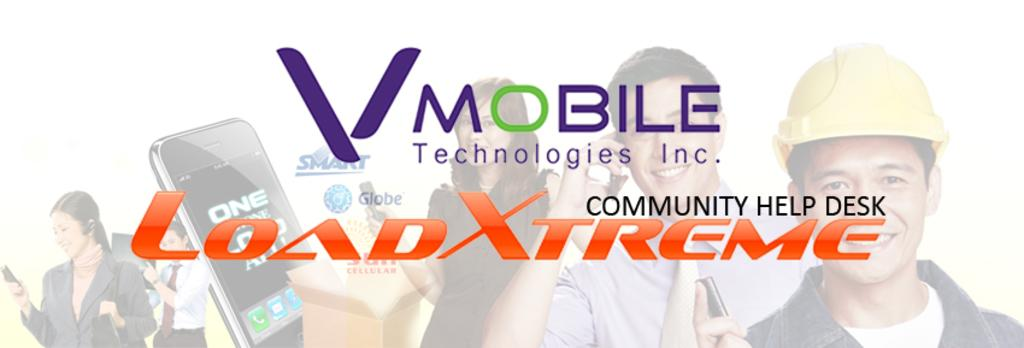What can be found in the image that contains written information? There is text in the image. What is the emotional state of the persons in the image? The persons in the image are smiling. What color are some of the objects in the image? There are black objects in the image. What other color can be seen among the objects in the image? There are brown objects in the image. What type of liquid is being poured in the image? There is no liquid being poured in the image; the facts provided do not mention any liquid. 